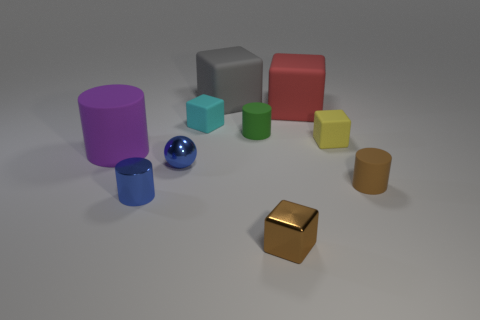Subtract all red blocks. How many blocks are left? 4 Subtract all tiny metal blocks. How many blocks are left? 4 Subtract all yellow cylinders. Subtract all yellow spheres. How many cylinders are left? 4 Subtract all balls. How many objects are left? 9 Subtract 0 cyan spheres. How many objects are left? 10 Subtract all big balls. Subtract all large red matte things. How many objects are left? 9 Add 6 tiny green matte cylinders. How many tiny green matte cylinders are left? 7 Add 9 big yellow shiny things. How many big yellow shiny things exist? 9 